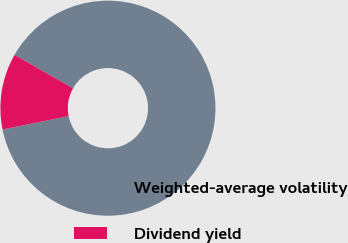<chart> <loc_0><loc_0><loc_500><loc_500><pie_chart><fcel>Weighted-average volatility<fcel>Dividend yield<nl><fcel>88.58%<fcel>11.42%<nl></chart> 